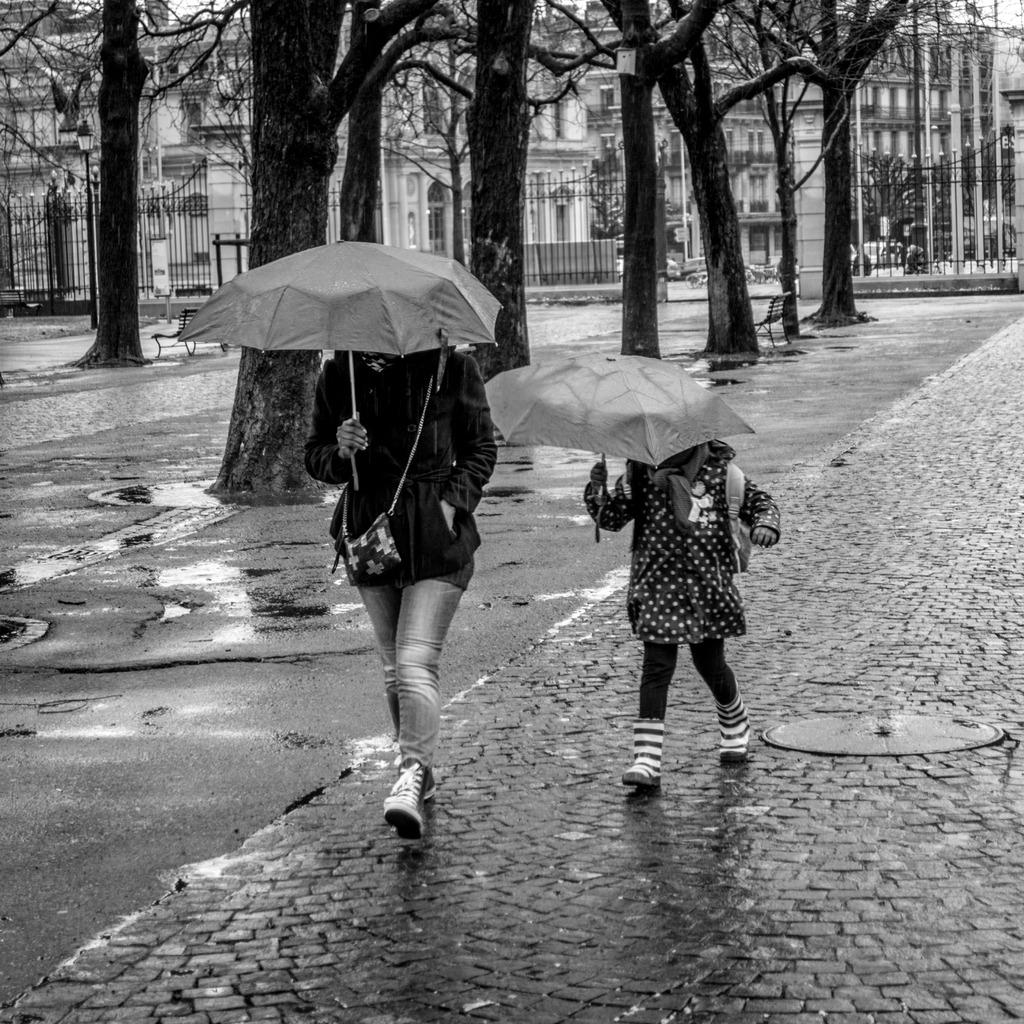Who is present in the image? There is a woman and a kid in the image. What are the woman and the kid holding? Both the woman and the kid are holding umbrellas. What can be seen in the background of the image? There are trees and buildings in the background of the image. What type of guitar can be seen in the image? There is no guitar present in the image. How low is the cart in the image? There is no cart present in the image. 